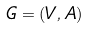<formula> <loc_0><loc_0><loc_500><loc_500>G = ( V , A )</formula> 